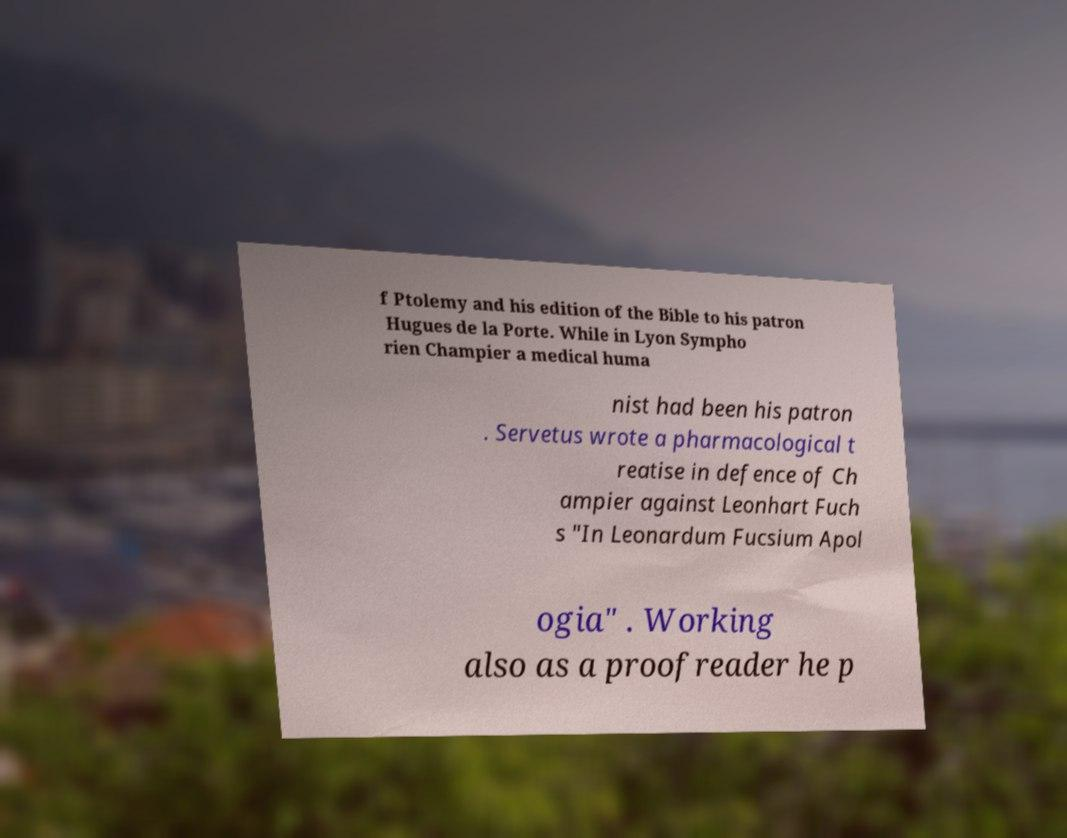For documentation purposes, I need the text within this image transcribed. Could you provide that? f Ptolemy and his edition of the Bible to his patron Hugues de la Porte. While in Lyon Sympho rien Champier a medical huma nist had been his patron . Servetus wrote a pharmacological t reatise in defence of Ch ampier against Leonhart Fuch s "In Leonardum Fucsium Apol ogia" . Working also as a proofreader he p 